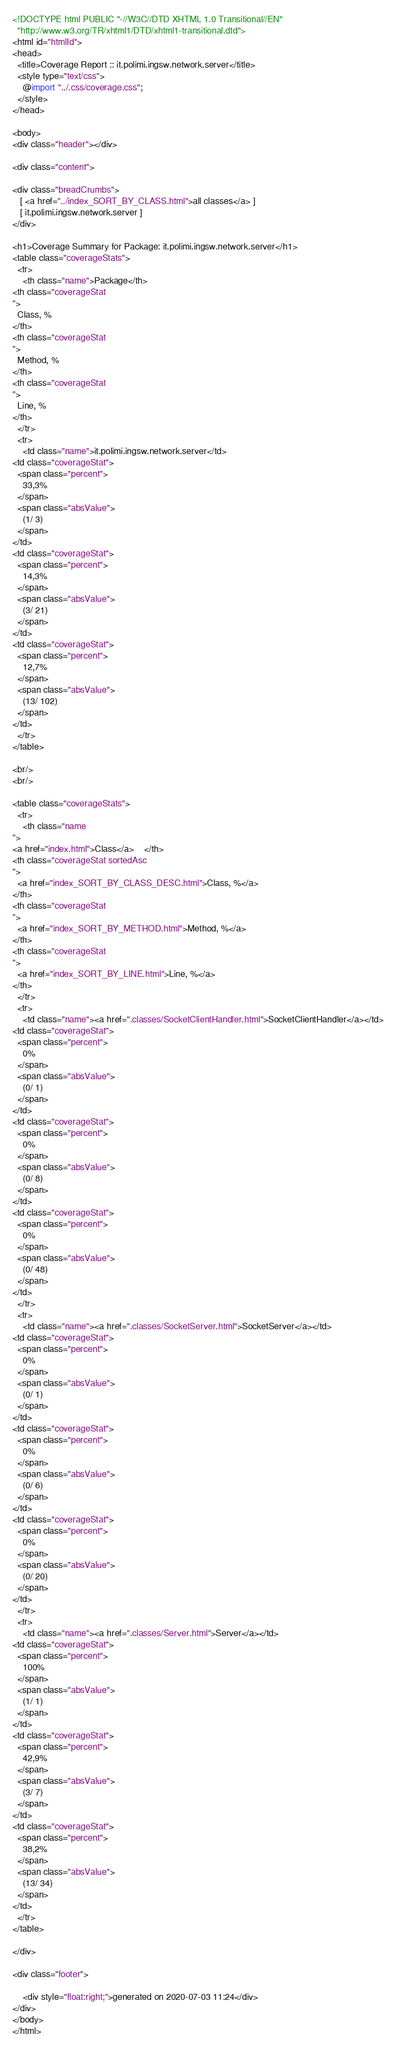Convert code to text. <code><loc_0><loc_0><loc_500><loc_500><_HTML_>
<!DOCTYPE html PUBLIC "-//W3C//DTD XHTML 1.0 Transitional//EN"
  "http://www.w3.org/TR/xhtml1/DTD/xhtml1-transitional.dtd">
<html id="htmlId">
<head>
  <title>Coverage Report :: it.polimi.ingsw.network.server</title>
  <style type="text/css">
    @import "../.css/coverage.css";
  </style>
</head>

<body>
<div class="header"></div>

<div class="content">

<div class="breadCrumbs">
   [ <a href="../index_SORT_BY_CLASS.html">all classes</a> ]
   [ it.polimi.ingsw.network.server ]
</div>

<h1>Coverage Summary for Package: it.polimi.ingsw.network.server</h1>
<table class="coverageStats">
  <tr>
    <th class="name">Package</th>
<th class="coverageStat 
">
  Class, %
</th>
<th class="coverageStat 
">
  Method, %
</th>
<th class="coverageStat 
">
  Line, %
</th>
  </tr>
  <tr>
    <td class="name">it.polimi.ingsw.network.server</td>
<td class="coverageStat">
  <span class="percent">
    33,3%
  </span>
  <span class="absValue">
    (1/ 3)
  </span>
</td>
<td class="coverageStat">
  <span class="percent">
    14,3%
  </span>
  <span class="absValue">
    (3/ 21)
  </span>
</td>
<td class="coverageStat">
  <span class="percent">
    12,7%
  </span>
  <span class="absValue">
    (13/ 102)
  </span>
</td>
  </tr>
</table>

<br/>
<br/>

<table class="coverageStats">
  <tr>
    <th class="name  
">
<a href="index.html">Class</a>    </th>
<th class="coverageStat sortedAsc
">
  <a href="index_SORT_BY_CLASS_DESC.html">Class, %</a>
</th>
<th class="coverageStat 
">
  <a href="index_SORT_BY_METHOD.html">Method, %</a>
</th>
<th class="coverageStat 
">
  <a href="index_SORT_BY_LINE.html">Line, %</a>
</th>
  </tr>
  <tr>
    <td class="name"><a href=".classes/SocketClientHandler.html">SocketClientHandler</a></td>
<td class="coverageStat">
  <span class="percent">
    0%
  </span>
  <span class="absValue">
    (0/ 1)
  </span>
</td>
<td class="coverageStat">
  <span class="percent">
    0%
  </span>
  <span class="absValue">
    (0/ 8)
  </span>
</td>
<td class="coverageStat">
  <span class="percent">
    0%
  </span>
  <span class="absValue">
    (0/ 48)
  </span>
</td>
  </tr>
  <tr>
    <td class="name"><a href=".classes/SocketServer.html">SocketServer</a></td>
<td class="coverageStat">
  <span class="percent">
    0%
  </span>
  <span class="absValue">
    (0/ 1)
  </span>
</td>
<td class="coverageStat">
  <span class="percent">
    0%
  </span>
  <span class="absValue">
    (0/ 6)
  </span>
</td>
<td class="coverageStat">
  <span class="percent">
    0%
  </span>
  <span class="absValue">
    (0/ 20)
  </span>
</td>
  </tr>
  <tr>
    <td class="name"><a href=".classes/Server.html">Server</a></td>
<td class="coverageStat">
  <span class="percent">
    100%
  </span>
  <span class="absValue">
    (1/ 1)
  </span>
</td>
<td class="coverageStat">
  <span class="percent">
    42,9%
  </span>
  <span class="absValue">
    (3/ 7)
  </span>
</td>
<td class="coverageStat">
  <span class="percent">
    38,2%
  </span>
  <span class="absValue">
    (13/ 34)
  </span>
</td>
  </tr>
</table>

</div>

<div class="footer">
    
    <div style="float:right;">generated on 2020-07-03 11:24</div>
</div>
</body>
</html>
</code> 